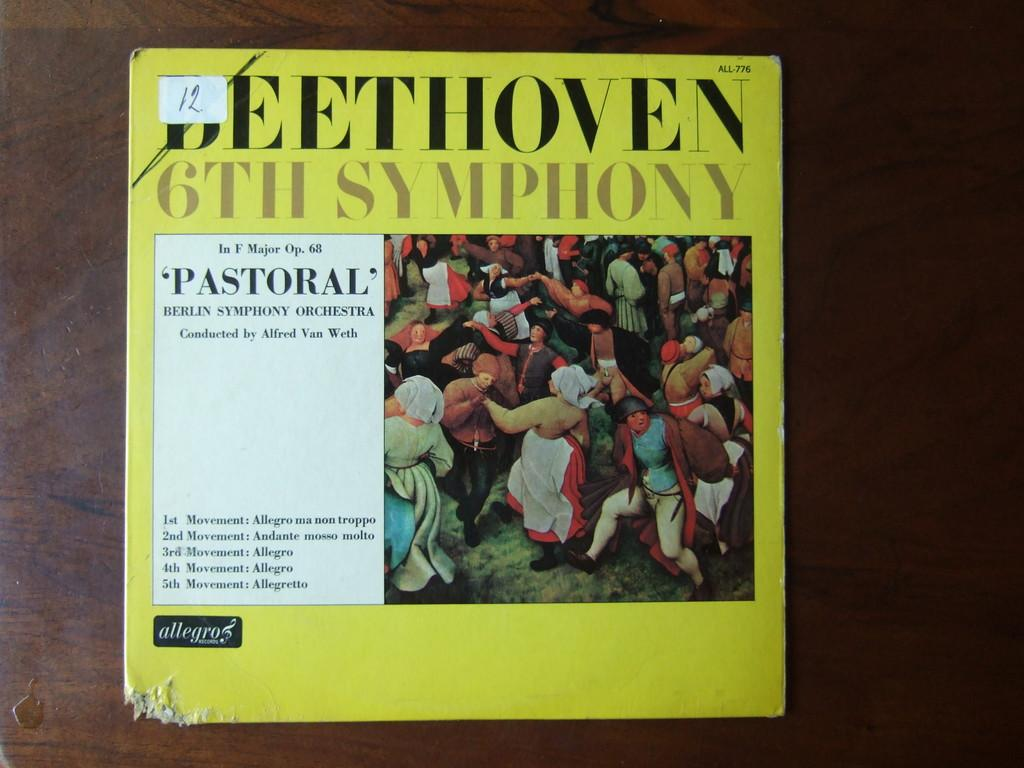Provide a one-sentence caption for the provided image. A yellow score book of Beethoven's Pastoral Symphony is on a table. 